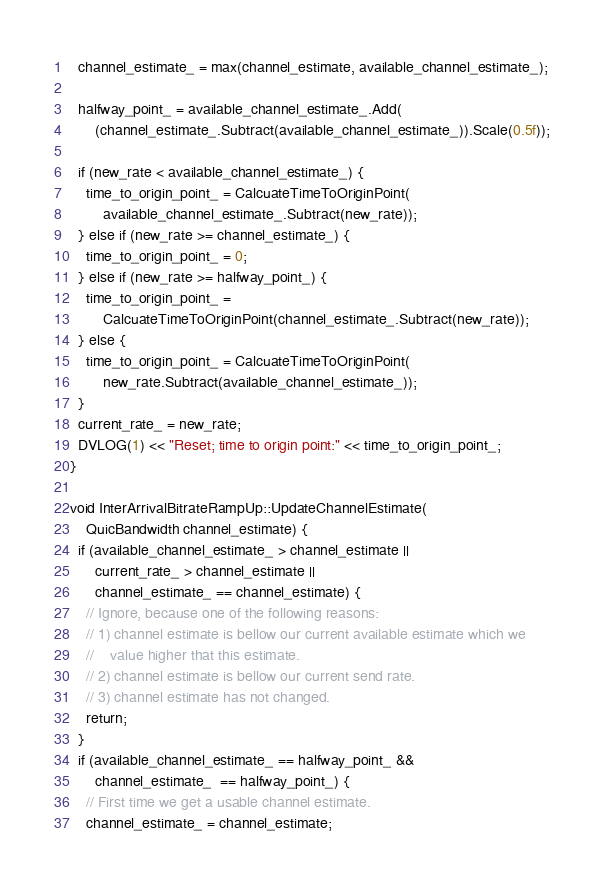<code> <loc_0><loc_0><loc_500><loc_500><_C++_>  channel_estimate_ = max(channel_estimate, available_channel_estimate_);

  halfway_point_ = available_channel_estimate_.Add(
      (channel_estimate_.Subtract(available_channel_estimate_)).Scale(0.5f));

  if (new_rate < available_channel_estimate_) {
    time_to_origin_point_ = CalcuateTimeToOriginPoint(
        available_channel_estimate_.Subtract(new_rate));
  } else if (new_rate >= channel_estimate_) {
    time_to_origin_point_ = 0;
  } else if (new_rate >= halfway_point_) {
    time_to_origin_point_ =
        CalcuateTimeToOriginPoint(channel_estimate_.Subtract(new_rate));
  } else {
    time_to_origin_point_ = CalcuateTimeToOriginPoint(
        new_rate.Subtract(available_channel_estimate_));
  }
  current_rate_ = new_rate;
  DVLOG(1) << "Reset; time to origin point:" << time_to_origin_point_;
}

void InterArrivalBitrateRampUp::UpdateChannelEstimate(
    QuicBandwidth channel_estimate) {
  if (available_channel_estimate_ > channel_estimate ||
      current_rate_ > channel_estimate ||
      channel_estimate_ == channel_estimate) {
    // Ignore, because one of the following reasons:
    // 1) channel estimate is bellow our current available estimate which we
    //    value higher that this estimate.
    // 2) channel estimate is bellow our current send rate.
    // 3) channel estimate has not changed.
    return;
  }
  if (available_channel_estimate_ == halfway_point_ &&
      channel_estimate_  == halfway_point_) {
    // First time we get a usable channel estimate.
    channel_estimate_ = channel_estimate;</code> 